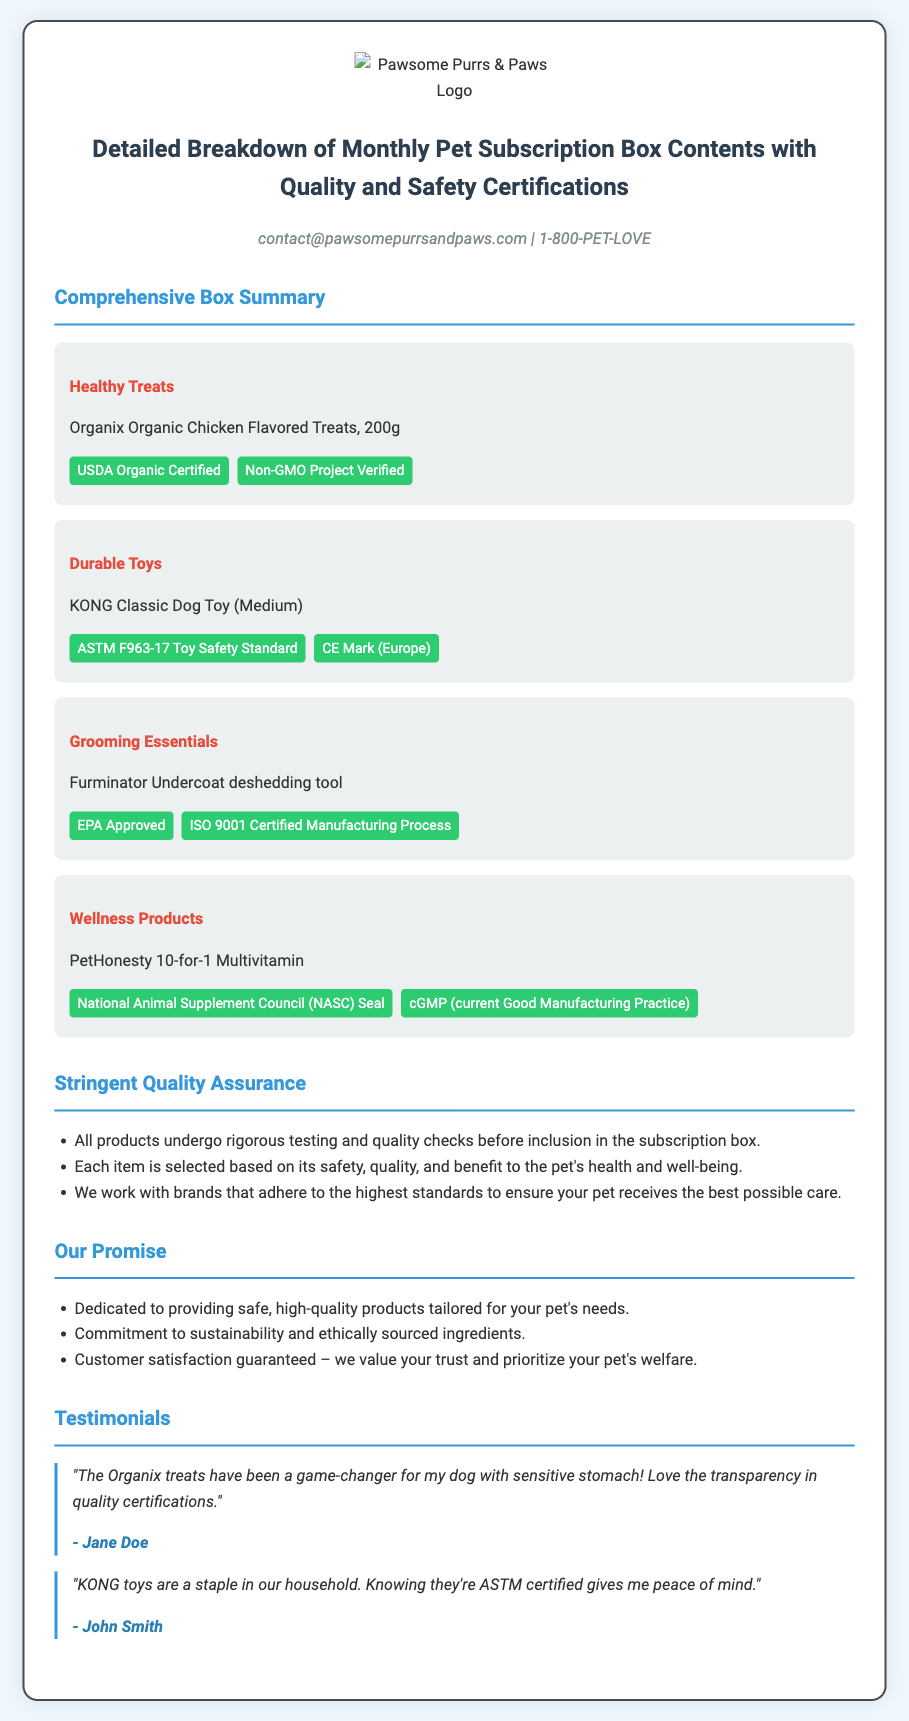What are the contents of the box? The box contains Healthy Treats, Durable Toys, Grooming Essentials, and Wellness Products.
Answer: Healthy Treats, Durable Toys, Grooming Essentials, Wellness Products What certification does the Organic Chicken Flavored Treats hold? The certification for the Organic Chicken Flavored Treats is mentioned in the document as USDA Organic Certified.
Answer: USDA Organic Certified What safety standard is mentioned for the KONG Classic Dog Toy? The document states that the KONG Classic Dog Toy adheres to the ASTM F963-17 Toy Safety Standard.
Answer: ASTM F963-17 Toy Safety Standard How many grams do the Organix Organic Chicken Flavored Treats weigh? The weight of the Organix Organic Chicken Flavored Treats is provided as 200 grams.
Answer: 200g What is the commitment of the company mentioned in the Our Promise section? The document specifies that the company's commitment includes providing safe, high-quality products tailored for your pet's needs.
Answer: Safe, high-quality products tailored for your pet's needs Which certification is shared by both the Furminator Undercoat deshedding tool and the PetHonesty Multivitamin? Both products list the ISO 9001 Certified Manufacturing Process and cGMP certifications, respectively, indicating quality assurance.
Answer: ISO 9001 Certified Manufacturing Process What type of customer feedback is included in the document? The testimonials provided in the document are from customers sharing their experiences with the products.
Answer: Customer testimonials 